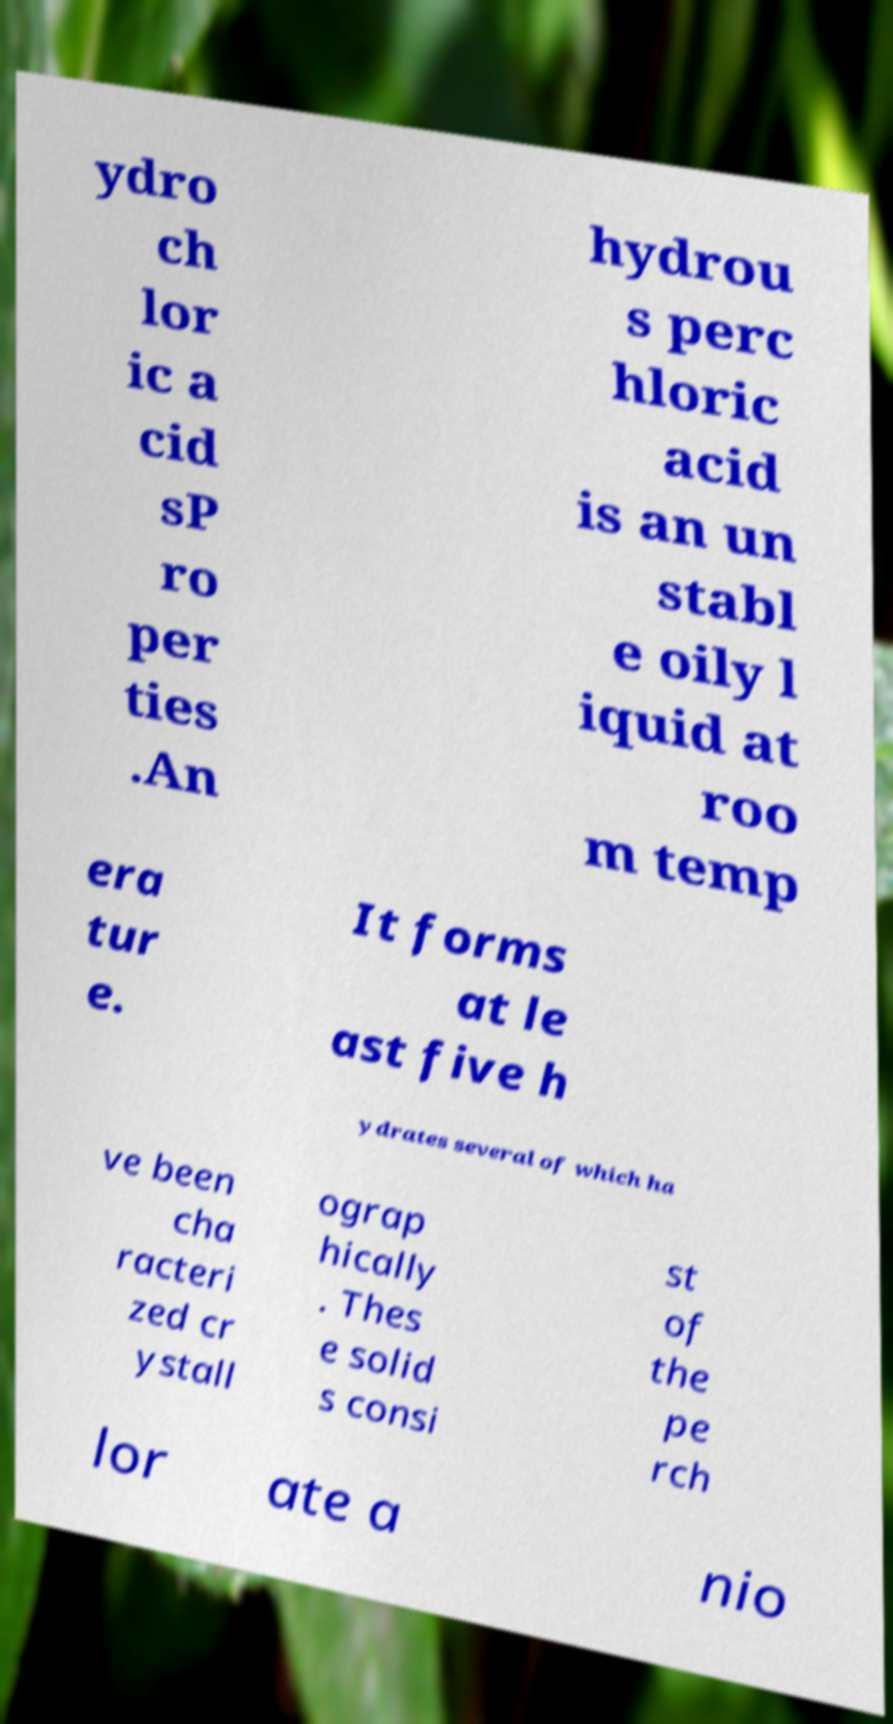What messages or text are displayed in this image? I need them in a readable, typed format. ydro ch lor ic a cid sP ro per ties .An hydrou s perc hloric acid is an un stabl e oily l iquid at roo m temp era tur e. It forms at le ast five h ydrates several of which ha ve been cha racteri zed cr ystall ograp hically . Thes e solid s consi st of the pe rch lor ate a nio 